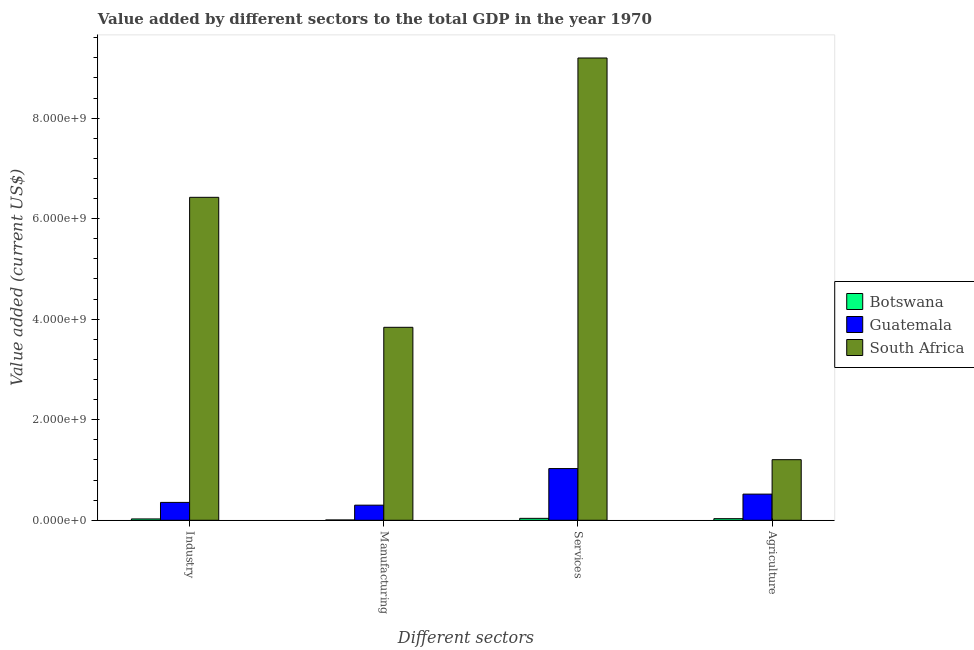How many different coloured bars are there?
Make the answer very short. 3. Are the number of bars per tick equal to the number of legend labels?
Your answer should be compact. Yes. Are the number of bars on each tick of the X-axis equal?
Ensure brevity in your answer.  Yes. How many bars are there on the 2nd tick from the left?
Provide a short and direct response. 3. How many bars are there on the 4th tick from the right?
Your answer should be very brief. 3. What is the label of the 1st group of bars from the left?
Give a very brief answer. Industry. What is the value added by industrial sector in Botswana?
Provide a succinct answer. 2.65e+07. Across all countries, what is the maximum value added by agricultural sector?
Ensure brevity in your answer.  1.21e+09. Across all countries, what is the minimum value added by services sector?
Offer a very short reply. 3.80e+07. In which country was the value added by agricultural sector maximum?
Provide a succinct answer. South Africa. In which country was the value added by services sector minimum?
Your answer should be compact. Botswana. What is the total value added by industrial sector in the graph?
Ensure brevity in your answer.  6.81e+09. What is the difference between the value added by manufacturing sector in South Africa and that in Botswana?
Keep it short and to the point. 3.83e+09. What is the difference between the value added by agricultural sector in Botswana and the value added by industrial sector in South Africa?
Make the answer very short. -6.39e+09. What is the average value added by manufacturing sector per country?
Provide a short and direct response. 1.38e+09. What is the difference between the value added by manufacturing sector and value added by services sector in South Africa?
Your answer should be compact. -5.36e+09. What is the ratio of the value added by services sector in Guatemala to that in Botswana?
Give a very brief answer. 27.09. Is the difference between the value added by services sector in Botswana and South Africa greater than the difference between the value added by industrial sector in Botswana and South Africa?
Provide a succinct answer. No. What is the difference between the highest and the second highest value added by industrial sector?
Keep it short and to the point. 6.07e+09. What is the difference between the highest and the lowest value added by services sector?
Offer a very short reply. 9.16e+09. What does the 3rd bar from the left in Industry represents?
Your answer should be very brief. South Africa. What does the 1st bar from the right in Manufacturing represents?
Offer a very short reply. South Africa. What is the difference between two consecutive major ticks on the Y-axis?
Your answer should be very brief. 2.00e+09. Are the values on the major ticks of Y-axis written in scientific E-notation?
Offer a terse response. Yes. Where does the legend appear in the graph?
Provide a short and direct response. Center right. How many legend labels are there?
Provide a short and direct response. 3. How are the legend labels stacked?
Offer a terse response. Vertical. What is the title of the graph?
Your response must be concise. Value added by different sectors to the total GDP in the year 1970. What is the label or title of the X-axis?
Ensure brevity in your answer.  Different sectors. What is the label or title of the Y-axis?
Give a very brief answer. Value added (current US$). What is the Value added (current US$) of Botswana in Industry?
Offer a terse response. 2.65e+07. What is the Value added (current US$) of Guatemala in Industry?
Make the answer very short. 3.55e+08. What is the Value added (current US$) in South Africa in Industry?
Offer a terse response. 6.42e+09. What is the Value added (current US$) in Botswana in Manufacturing?
Make the answer very short. 5.65e+06. What is the Value added (current US$) of Guatemala in Manufacturing?
Provide a short and direct response. 3.01e+08. What is the Value added (current US$) in South Africa in Manufacturing?
Give a very brief answer. 3.84e+09. What is the Value added (current US$) in Botswana in Services?
Keep it short and to the point. 3.80e+07. What is the Value added (current US$) of Guatemala in Services?
Your answer should be very brief. 1.03e+09. What is the Value added (current US$) of South Africa in Services?
Provide a short and direct response. 9.20e+09. What is the Value added (current US$) in Botswana in Agriculture?
Ensure brevity in your answer.  3.18e+07. What is the Value added (current US$) of Guatemala in Agriculture?
Make the answer very short. 5.20e+08. What is the Value added (current US$) of South Africa in Agriculture?
Offer a very short reply. 1.21e+09. Across all Different sectors, what is the maximum Value added (current US$) in Botswana?
Ensure brevity in your answer.  3.80e+07. Across all Different sectors, what is the maximum Value added (current US$) in Guatemala?
Provide a succinct answer. 1.03e+09. Across all Different sectors, what is the maximum Value added (current US$) in South Africa?
Provide a short and direct response. 9.20e+09. Across all Different sectors, what is the minimum Value added (current US$) in Botswana?
Provide a succinct answer. 5.65e+06. Across all Different sectors, what is the minimum Value added (current US$) in Guatemala?
Offer a terse response. 3.01e+08. Across all Different sectors, what is the minimum Value added (current US$) of South Africa?
Make the answer very short. 1.21e+09. What is the total Value added (current US$) in Botswana in the graph?
Provide a short and direct response. 1.02e+08. What is the total Value added (current US$) in Guatemala in the graph?
Your answer should be very brief. 2.20e+09. What is the total Value added (current US$) in South Africa in the graph?
Give a very brief answer. 2.07e+1. What is the difference between the Value added (current US$) of Botswana in Industry and that in Manufacturing?
Provide a succinct answer. 2.09e+07. What is the difference between the Value added (current US$) of Guatemala in Industry and that in Manufacturing?
Provide a short and direct response. 5.48e+07. What is the difference between the Value added (current US$) of South Africa in Industry and that in Manufacturing?
Keep it short and to the point. 2.59e+09. What is the difference between the Value added (current US$) of Botswana in Industry and that in Services?
Give a very brief answer. -1.14e+07. What is the difference between the Value added (current US$) in Guatemala in Industry and that in Services?
Your answer should be very brief. -6.73e+08. What is the difference between the Value added (current US$) in South Africa in Industry and that in Services?
Your answer should be compact. -2.77e+09. What is the difference between the Value added (current US$) in Botswana in Industry and that in Agriculture?
Offer a terse response. -5.23e+06. What is the difference between the Value added (current US$) of Guatemala in Industry and that in Agriculture?
Provide a short and direct response. -1.65e+08. What is the difference between the Value added (current US$) in South Africa in Industry and that in Agriculture?
Your response must be concise. 5.22e+09. What is the difference between the Value added (current US$) of Botswana in Manufacturing and that in Services?
Keep it short and to the point. -3.23e+07. What is the difference between the Value added (current US$) in Guatemala in Manufacturing and that in Services?
Your answer should be very brief. -7.28e+08. What is the difference between the Value added (current US$) in South Africa in Manufacturing and that in Services?
Offer a terse response. -5.36e+09. What is the difference between the Value added (current US$) of Botswana in Manufacturing and that in Agriculture?
Offer a terse response. -2.61e+07. What is the difference between the Value added (current US$) in Guatemala in Manufacturing and that in Agriculture?
Ensure brevity in your answer.  -2.20e+08. What is the difference between the Value added (current US$) in South Africa in Manufacturing and that in Agriculture?
Offer a terse response. 2.63e+09. What is the difference between the Value added (current US$) of Botswana in Services and that in Agriculture?
Give a very brief answer. 6.21e+06. What is the difference between the Value added (current US$) in Guatemala in Services and that in Agriculture?
Ensure brevity in your answer.  5.08e+08. What is the difference between the Value added (current US$) of South Africa in Services and that in Agriculture?
Make the answer very short. 7.99e+09. What is the difference between the Value added (current US$) of Botswana in Industry and the Value added (current US$) of Guatemala in Manufacturing?
Provide a succinct answer. -2.74e+08. What is the difference between the Value added (current US$) in Botswana in Industry and the Value added (current US$) in South Africa in Manufacturing?
Make the answer very short. -3.81e+09. What is the difference between the Value added (current US$) in Guatemala in Industry and the Value added (current US$) in South Africa in Manufacturing?
Make the answer very short. -3.48e+09. What is the difference between the Value added (current US$) in Botswana in Industry and the Value added (current US$) in Guatemala in Services?
Your answer should be compact. -1.00e+09. What is the difference between the Value added (current US$) in Botswana in Industry and the Value added (current US$) in South Africa in Services?
Your answer should be compact. -9.17e+09. What is the difference between the Value added (current US$) of Guatemala in Industry and the Value added (current US$) of South Africa in Services?
Your answer should be very brief. -8.84e+09. What is the difference between the Value added (current US$) of Botswana in Industry and the Value added (current US$) of Guatemala in Agriculture?
Offer a terse response. -4.94e+08. What is the difference between the Value added (current US$) in Botswana in Industry and the Value added (current US$) in South Africa in Agriculture?
Offer a terse response. -1.18e+09. What is the difference between the Value added (current US$) of Guatemala in Industry and the Value added (current US$) of South Africa in Agriculture?
Your answer should be very brief. -8.50e+08. What is the difference between the Value added (current US$) of Botswana in Manufacturing and the Value added (current US$) of Guatemala in Services?
Offer a terse response. -1.02e+09. What is the difference between the Value added (current US$) in Botswana in Manufacturing and the Value added (current US$) in South Africa in Services?
Give a very brief answer. -9.19e+09. What is the difference between the Value added (current US$) in Guatemala in Manufacturing and the Value added (current US$) in South Africa in Services?
Offer a terse response. -8.90e+09. What is the difference between the Value added (current US$) in Botswana in Manufacturing and the Value added (current US$) in Guatemala in Agriculture?
Give a very brief answer. -5.14e+08. What is the difference between the Value added (current US$) of Botswana in Manufacturing and the Value added (current US$) of South Africa in Agriculture?
Give a very brief answer. -1.20e+09. What is the difference between the Value added (current US$) of Guatemala in Manufacturing and the Value added (current US$) of South Africa in Agriculture?
Offer a terse response. -9.05e+08. What is the difference between the Value added (current US$) of Botswana in Services and the Value added (current US$) of Guatemala in Agriculture?
Provide a short and direct response. -4.82e+08. What is the difference between the Value added (current US$) of Botswana in Services and the Value added (current US$) of South Africa in Agriculture?
Keep it short and to the point. -1.17e+09. What is the difference between the Value added (current US$) in Guatemala in Services and the Value added (current US$) in South Africa in Agriculture?
Your answer should be very brief. -1.77e+08. What is the average Value added (current US$) of Botswana per Different sectors?
Your answer should be very brief. 2.55e+07. What is the average Value added (current US$) in Guatemala per Different sectors?
Your answer should be very brief. 5.51e+08. What is the average Value added (current US$) of South Africa per Different sectors?
Keep it short and to the point. 5.17e+09. What is the difference between the Value added (current US$) in Botswana and Value added (current US$) in Guatemala in Industry?
Keep it short and to the point. -3.29e+08. What is the difference between the Value added (current US$) of Botswana and Value added (current US$) of South Africa in Industry?
Your response must be concise. -6.40e+09. What is the difference between the Value added (current US$) of Guatemala and Value added (current US$) of South Africa in Industry?
Your answer should be very brief. -6.07e+09. What is the difference between the Value added (current US$) of Botswana and Value added (current US$) of Guatemala in Manufacturing?
Offer a terse response. -2.95e+08. What is the difference between the Value added (current US$) of Botswana and Value added (current US$) of South Africa in Manufacturing?
Your response must be concise. -3.83e+09. What is the difference between the Value added (current US$) of Guatemala and Value added (current US$) of South Africa in Manufacturing?
Keep it short and to the point. -3.54e+09. What is the difference between the Value added (current US$) in Botswana and Value added (current US$) in Guatemala in Services?
Make the answer very short. -9.91e+08. What is the difference between the Value added (current US$) in Botswana and Value added (current US$) in South Africa in Services?
Keep it short and to the point. -9.16e+09. What is the difference between the Value added (current US$) of Guatemala and Value added (current US$) of South Africa in Services?
Provide a succinct answer. -8.17e+09. What is the difference between the Value added (current US$) of Botswana and Value added (current US$) of Guatemala in Agriculture?
Offer a terse response. -4.88e+08. What is the difference between the Value added (current US$) in Botswana and Value added (current US$) in South Africa in Agriculture?
Give a very brief answer. -1.17e+09. What is the difference between the Value added (current US$) of Guatemala and Value added (current US$) of South Africa in Agriculture?
Offer a terse response. -6.85e+08. What is the ratio of the Value added (current US$) of Botswana in Industry to that in Manufacturing?
Give a very brief answer. 4.69. What is the ratio of the Value added (current US$) of Guatemala in Industry to that in Manufacturing?
Offer a terse response. 1.18. What is the ratio of the Value added (current US$) in South Africa in Industry to that in Manufacturing?
Provide a short and direct response. 1.67. What is the ratio of the Value added (current US$) of Botswana in Industry to that in Services?
Provide a short and direct response. 0.7. What is the ratio of the Value added (current US$) of Guatemala in Industry to that in Services?
Your response must be concise. 0.35. What is the ratio of the Value added (current US$) in South Africa in Industry to that in Services?
Your answer should be compact. 0.7. What is the ratio of the Value added (current US$) in Botswana in Industry to that in Agriculture?
Provide a short and direct response. 0.84. What is the ratio of the Value added (current US$) in Guatemala in Industry to that in Agriculture?
Offer a very short reply. 0.68. What is the ratio of the Value added (current US$) in South Africa in Industry to that in Agriculture?
Give a very brief answer. 5.33. What is the ratio of the Value added (current US$) of Botswana in Manufacturing to that in Services?
Your response must be concise. 0.15. What is the ratio of the Value added (current US$) in Guatemala in Manufacturing to that in Services?
Offer a very short reply. 0.29. What is the ratio of the Value added (current US$) of South Africa in Manufacturing to that in Services?
Keep it short and to the point. 0.42. What is the ratio of the Value added (current US$) of Botswana in Manufacturing to that in Agriculture?
Offer a terse response. 0.18. What is the ratio of the Value added (current US$) of Guatemala in Manufacturing to that in Agriculture?
Your answer should be compact. 0.58. What is the ratio of the Value added (current US$) in South Africa in Manufacturing to that in Agriculture?
Provide a short and direct response. 3.18. What is the ratio of the Value added (current US$) of Botswana in Services to that in Agriculture?
Give a very brief answer. 1.2. What is the ratio of the Value added (current US$) in Guatemala in Services to that in Agriculture?
Your answer should be very brief. 1.98. What is the ratio of the Value added (current US$) in South Africa in Services to that in Agriculture?
Your answer should be compact. 7.63. What is the difference between the highest and the second highest Value added (current US$) of Botswana?
Provide a succinct answer. 6.21e+06. What is the difference between the highest and the second highest Value added (current US$) of Guatemala?
Provide a short and direct response. 5.08e+08. What is the difference between the highest and the second highest Value added (current US$) in South Africa?
Provide a short and direct response. 2.77e+09. What is the difference between the highest and the lowest Value added (current US$) of Botswana?
Give a very brief answer. 3.23e+07. What is the difference between the highest and the lowest Value added (current US$) of Guatemala?
Give a very brief answer. 7.28e+08. What is the difference between the highest and the lowest Value added (current US$) of South Africa?
Keep it short and to the point. 7.99e+09. 